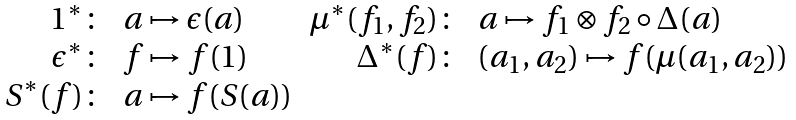Convert formula to latex. <formula><loc_0><loc_0><loc_500><loc_500>\begin{array} { r l r l } { { 1 ^ { * } \colon } } & { a \mapsto \epsilon ( a ) } & { { \mu ^ { * } ( f _ { 1 } , f _ { 2 } ) \colon } } & { { a \mapsto f _ { 1 } \otimes f _ { 2 } \circ \Delta ( a ) } } \\ { { \epsilon ^ { * } \colon } } & { f \mapsto f ( 1 ) } & { { \Delta ^ { * } ( f ) \colon } } & { { ( a _ { 1 } , a _ { 2 } ) \mapsto f ( \mu ( a _ { 1 } , a _ { 2 } ) ) } } \\ { { S ^ { * } ( f ) \colon } } & { a \mapsto f ( S ( a ) ) } \end{array}</formula> 